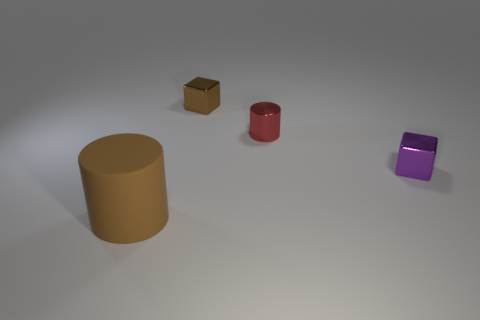What can you tell me about the lighting and shadows in the scene? The lighting in the scene casts soft shadows to the sides and behind the objects, suggesting a light source positioned above and slightly in front of them. The shadows are slightly elongated, indicating the light source is not directly overhead, which adds a sense of depth to the scene. 